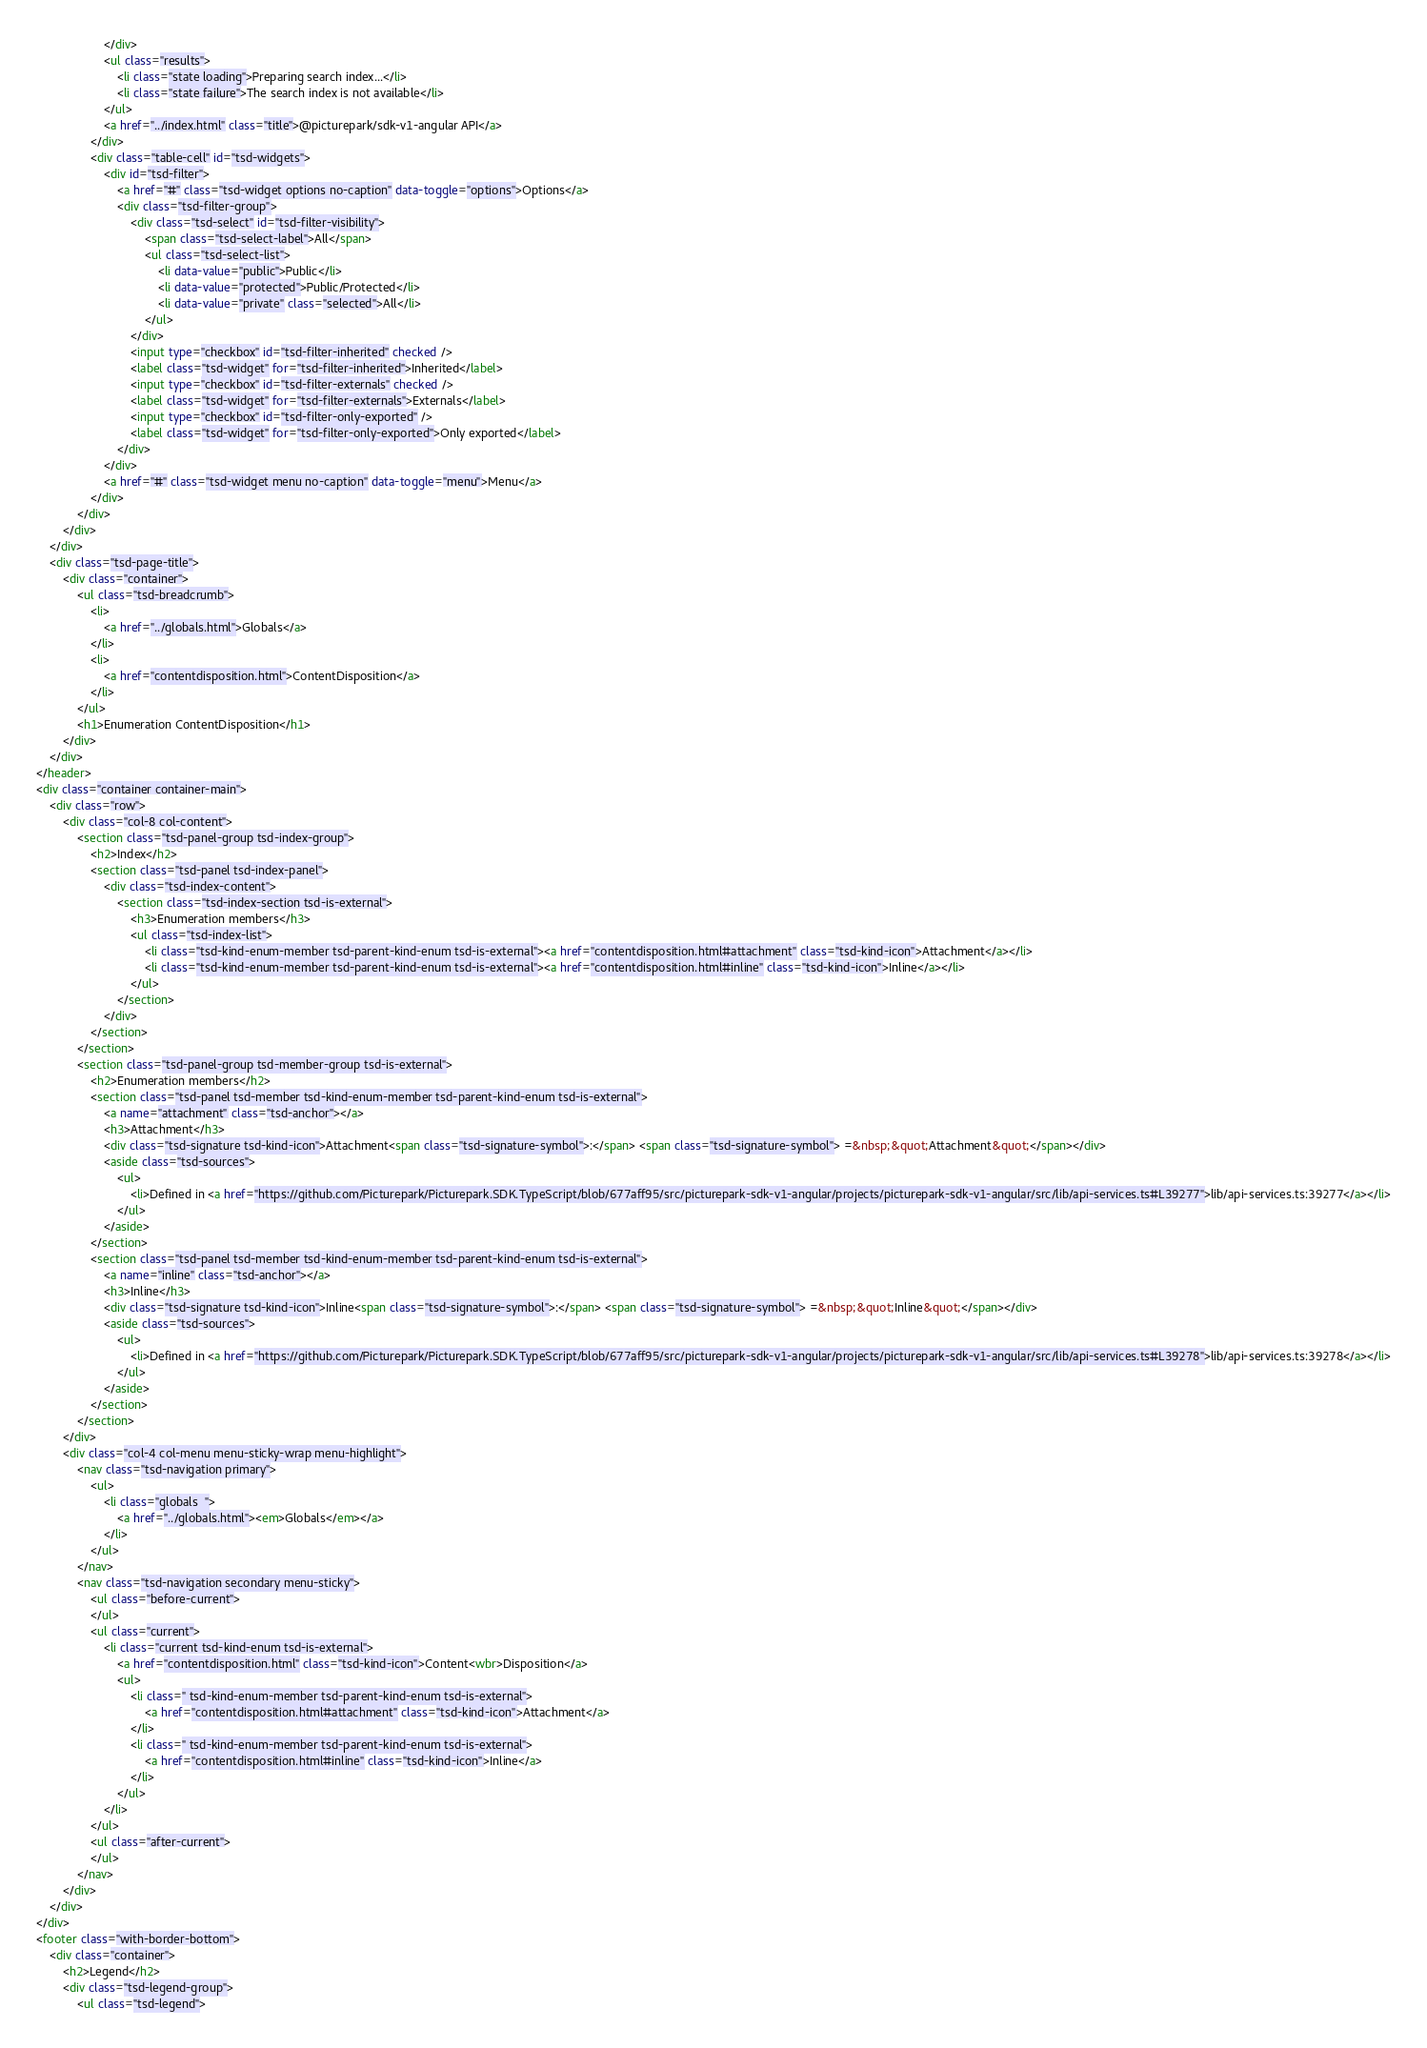<code> <loc_0><loc_0><loc_500><loc_500><_HTML_>					</div>
					<ul class="results">
						<li class="state loading">Preparing search index...</li>
						<li class="state failure">The search index is not available</li>
					</ul>
					<a href="../index.html" class="title">@picturepark/sdk-v1-angular API</a>
				</div>
				<div class="table-cell" id="tsd-widgets">
					<div id="tsd-filter">
						<a href="#" class="tsd-widget options no-caption" data-toggle="options">Options</a>
						<div class="tsd-filter-group">
							<div class="tsd-select" id="tsd-filter-visibility">
								<span class="tsd-select-label">All</span>
								<ul class="tsd-select-list">
									<li data-value="public">Public</li>
									<li data-value="protected">Public/Protected</li>
									<li data-value="private" class="selected">All</li>
								</ul>
							</div>
							<input type="checkbox" id="tsd-filter-inherited" checked />
							<label class="tsd-widget" for="tsd-filter-inherited">Inherited</label>
							<input type="checkbox" id="tsd-filter-externals" checked />
							<label class="tsd-widget" for="tsd-filter-externals">Externals</label>
							<input type="checkbox" id="tsd-filter-only-exported" />
							<label class="tsd-widget" for="tsd-filter-only-exported">Only exported</label>
						</div>
					</div>
					<a href="#" class="tsd-widget menu no-caption" data-toggle="menu">Menu</a>
				</div>
			</div>
		</div>
	</div>
	<div class="tsd-page-title">
		<div class="container">
			<ul class="tsd-breadcrumb">
				<li>
					<a href="../globals.html">Globals</a>
				</li>
				<li>
					<a href="contentdisposition.html">ContentDisposition</a>
				</li>
			</ul>
			<h1>Enumeration ContentDisposition</h1>
		</div>
	</div>
</header>
<div class="container container-main">
	<div class="row">
		<div class="col-8 col-content">
			<section class="tsd-panel-group tsd-index-group">
				<h2>Index</h2>
				<section class="tsd-panel tsd-index-panel">
					<div class="tsd-index-content">
						<section class="tsd-index-section tsd-is-external">
							<h3>Enumeration members</h3>
							<ul class="tsd-index-list">
								<li class="tsd-kind-enum-member tsd-parent-kind-enum tsd-is-external"><a href="contentdisposition.html#attachment" class="tsd-kind-icon">Attachment</a></li>
								<li class="tsd-kind-enum-member tsd-parent-kind-enum tsd-is-external"><a href="contentdisposition.html#inline" class="tsd-kind-icon">Inline</a></li>
							</ul>
						</section>
					</div>
				</section>
			</section>
			<section class="tsd-panel-group tsd-member-group tsd-is-external">
				<h2>Enumeration members</h2>
				<section class="tsd-panel tsd-member tsd-kind-enum-member tsd-parent-kind-enum tsd-is-external">
					<a name="attachment" class="tsd-anchor"></a>
					<h3>Attachment</h3>
					<div class="tsd-signature tsd-kind-icon">Attachment<span class="tsd-signature-symbol">:</span> <span class="tsd-signature-symbol"> =&nbsp;&quot;Attachment&quot;</span></div>
					<aside class="tsd-sources">
						<ul>
							<li>Defined in <a href="https://github.com/Picturepark/Picturepark.SDK.TypeScript/blob/677aff95/src/picturepark-sdk-v1-angular/projects/picturepark-sdk-v1-angular/src/lib/api-services.ts#L39277">lib/api-services.ts:39277</a></li>
						</ul>
					</aside>
				</section>
				<section class="tsd-panel tsd-member tsd-kind-enum-member tsd-parent-kind-enum tsd-is-external">
					<a name="inline" class="tsd-anchor"></a>
					<h3>Inline</h3>
					<div class="tsd-signature tsd-kind-icon">Inline<span class="tsd-signature-symbol">:</span> <span class="tsd-signature-symbol"> =&nbsp;&quot;Inline&quot;</span></div>
					<aside class="tsd-sources">
						<ul>
							<li>Defined in <a href="https://github.com/Picturepark/Picturepark.SDK.TypeScript/blob/677aff95/src/picturepark-sdk-v1-angular/projects/picturepark-sdk-v1-angular/src/lib/api-services.ts#L39278">lib/api-services.ts:39278</a></li>
						</ul>
					</aside>
				</section>
			</section>
		</div>
		<div class="col-4 col-menu menu-sticky-wrap menu-highlight">
			<nav class="tsd-navigation primary">
				<ul>
					<li class="globals  ">
						<a href="../globals.html"><em>Globals</em></a>
					</li>
				</ul>
			</nav>
			<nav class="tsd-navigation secondary menu-sticky">
				<ul class="before-current">
				</ul>
				<ul class="current">
					<li class="current tsd-kind-enum tsd-is-external">
						<a href="contentdisposition.html" class="tsd-kind-icon">Content<wbr>Disposition</a>
						<ul>
							<li class=" tsd-kind-enum-member tsd-parent-kind-enum tsd-is-external">
								<a href="contentdisposition.html#attachment" class="tsd-kind-icon">Attachment</a>
							</li>
							<li class=" tsd-kind-enum-member tsd-parent-kind-enum tsd-is-external">
								<a href="contentdisposition.html#inline" class="tsd-kind-icon">Inline</a>
							</li>
						</ul>
					</li>
				</ul>
				<ul class="after-current">
				</ul>
			</nav>
		</div>
	</div>
</div>
<footer class="with-border-bottom">
	<div class="container">
		<h2>Legend</h2>
		<div class="tsd-legend-group">
			<ul class="tsd-legend"></code> 